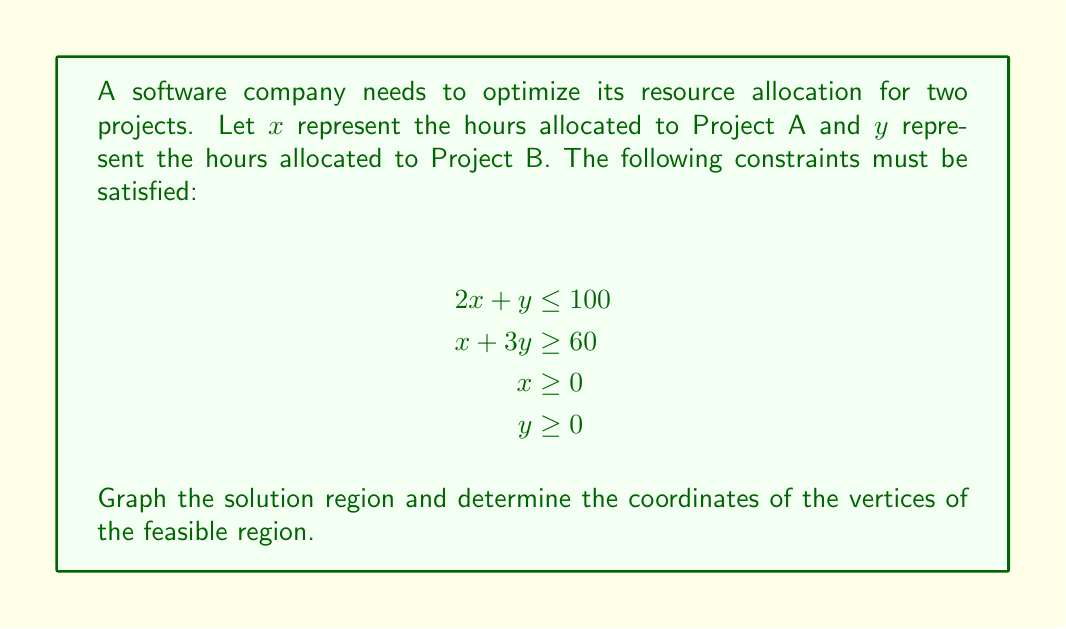Can you solve this math problem? To solve this system of linear inequalities and graph the solution:

1. Graph each inequality:
   a) $2x + y \leq 100$: Plot y-intercept (0, 100) and x-intercept (50, 0)
   b) $x + 3y \geq 60$: Plot y-intercept (0, 20) and x-intercept (60, 0)
   c) $x \geq 0$: Vertical line at x = 0
   d) $y \geq 0$: Horizontal line at y = 0

2. Shade the regions:
   - For $\leq$, shade below the line
   - For $\geq$, shade above the line
   - For $x \geq 0$ and $y \geq 0$, shade to the right and above, respectively

3. The solution region is the intersection of all shaded areas.

4. Find the vertices by solving the equations of intersecting lines:
   a) $2x + y = 100$ and $x + 3y = 60$:
      Subtract the second equation from twice the first:
      $4x + 2y = 200$
      $2x + 6y = 120$
      $2x - 4y = 80$
      $x - 2y = 40$
      $y = 20$, $x = 60$
   b) $2x + y = 100$ and $y = 0$:
      $2x = 100$, $x = 50$, $y = 0$
   c) $x + 3y = 60$ and $x = 0$:
      $3y = 60$, $y = 20$, $x = 0$

[asy]
import graph;
size(200);
xaxis("x", 0, 70, arrow=Arrow);
yaxis("y", 0, 40, arrow=Arrow);

draw((0,100)--(50,0), blue);
draw((0,20)--(60,0), red);

fill((0,20)--(0,40)--(60,20)--(50,0)--(0,0)--cycle, paleblue+opacity(0.2));

dot((0,20));
dot((60,20));
dot((50,0));

label("(0,20)", (0,20), W);
label("(60,20)", (60,20), E);
label("(50,0)", (50,0), S);

label("2x + y = 100", (25,50), NW, blue);
label("x + 3y = 60", (30,10), SE, red);
[/asy]
Answer: Vertices: (0, 20), (60, 20), (50, 0) 